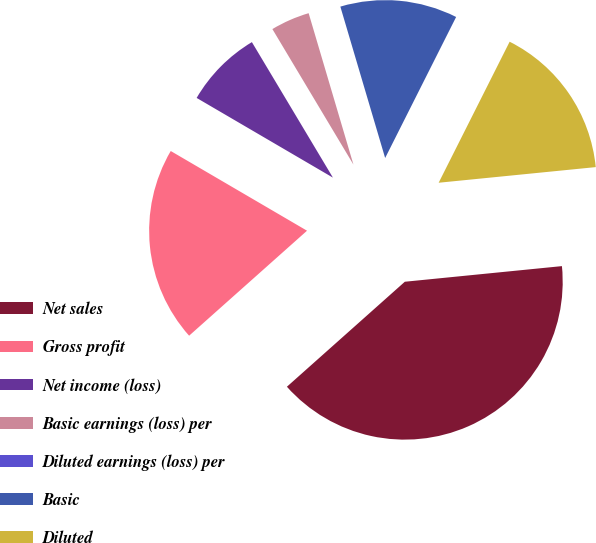Convert chart. <chart><loc_0><loc_0><loc_500><loc_500><pie_chart><fcel>Net sales<fcel>Gross profit<fcel>Net income (loss)<fcel>Basic earnings (loss) per<fcel>Diluted earnings (loss) per<fcel>Basic<fcel>Diluted<nl><fcel>40.0%<fcel>20.0%<fcel>8.0%<fcel>4.0%<fcel>0.0%<fcel>12.0%<fcel>16.0%<nl></chart> 